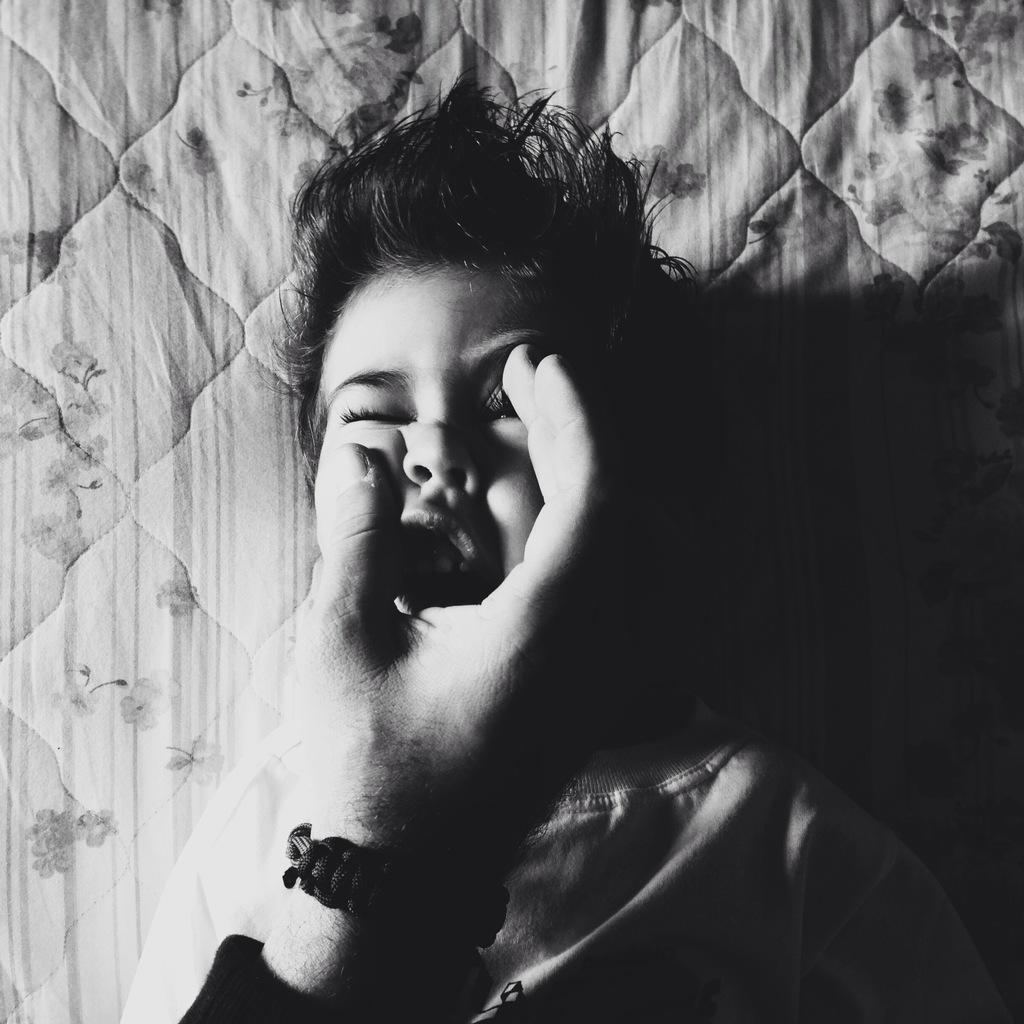What is the main subject of the image? There is a baby in the image. What is the baby's position in the image? The baby is laying down. Whose hand is visible in the image? There is a person's hand visible in the image. What is the color scheme of the image? The image is in black and white. What type of tools does the cook use in the image? There is no cook or tools present in the image; it features a baby laying down and a person's hand. What type of woodworking tasks is the carpenter performing in the image? There is no carpenter or woodworking tasks present in the image; it features a baby laying down and a person's hand. 